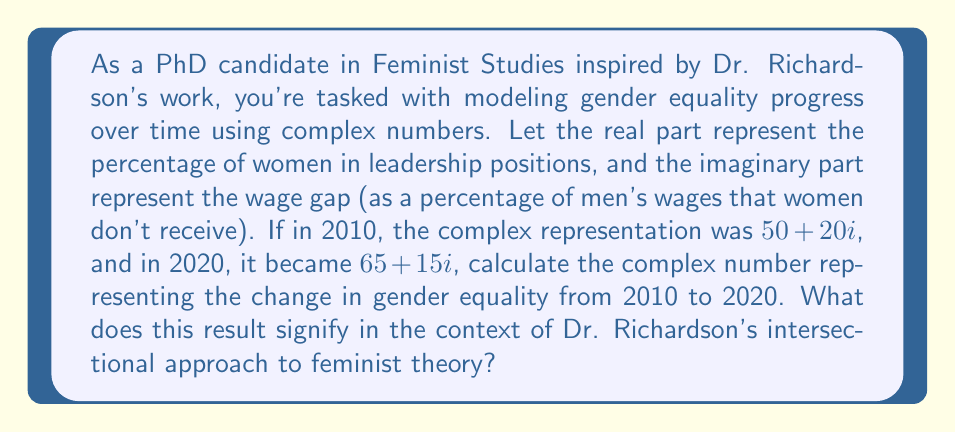Teach me how to tackle this problem. To solve this problem, we need to subtract the 2010 complex number from the 2020 complex number:

$$(65 + 15i) - (50 + 20i)$$

Let's break this down step-by-step:

1) First, we subtract the real parts:
   $65 - 50 = 15$

2) Then, we subtract the imaginary parts:
   $15i - 20i = -5i$

3) Combining these results, we get:
   $15 - 5i$

Interpreting this result:
- The real part (15) represents an increase of 15 percentage points in women's leadership positions.
- The imaginary part (-5i) represents a decrease of 5 percentage points in the wage gap.

In the context of Dr. Richardson's intersectional approach:
- The positive real part shows progress in representation, aligning with her emphasis on diverse leadership.
- The negative imaginary part indicates progress in economic equality, reflecting her focus on systemic barriers.
- The complex number format itself embodies the intersectional view, showing how different aspects of equality are interconnected and must be considered together.
Answer: $15 - 5i$ 